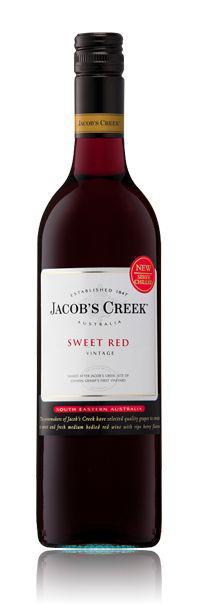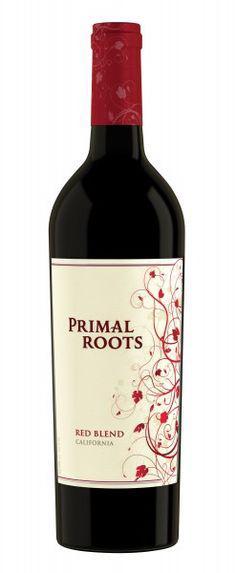The first image is the image on the left, the second image is the image on the right. Examine the images to the left and right. Is the description "The bottle in the image on the left has a screw-off cap." accurate? Answer yes or no. Yes. 